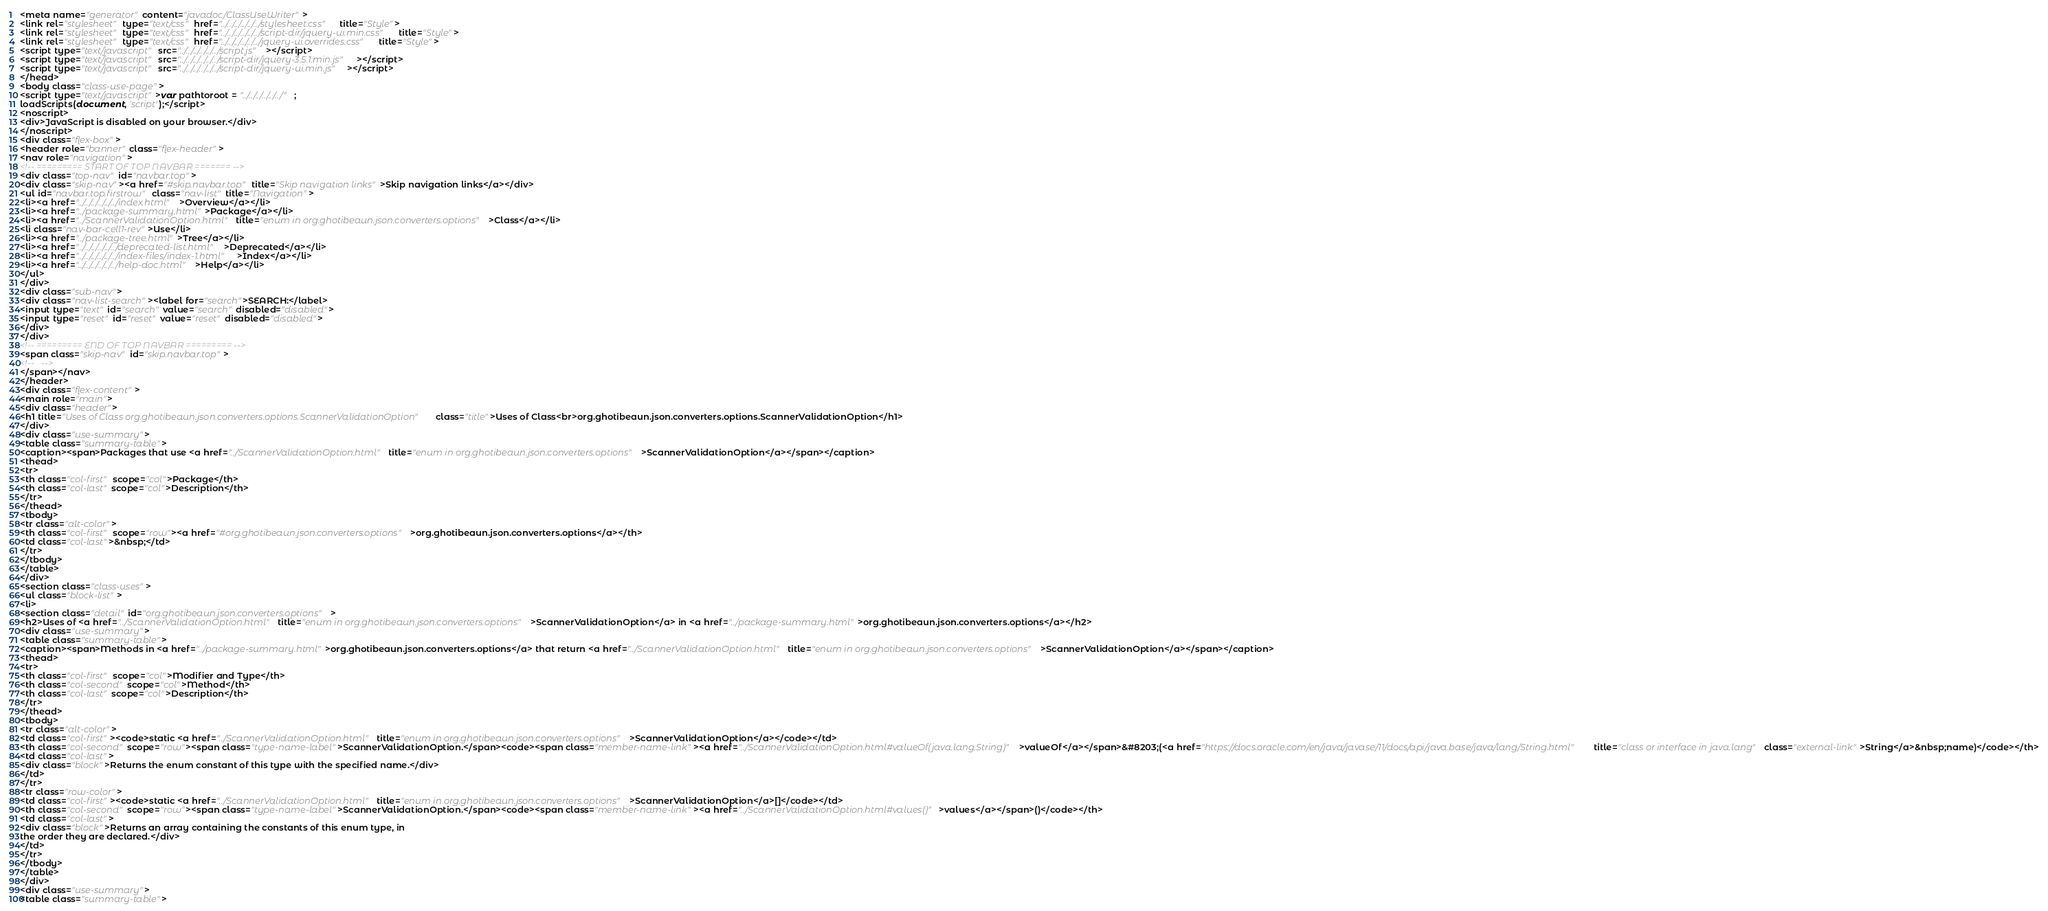Convert code to text. <code><loc_0><loc_0><loc_500><loc_500><_HTML_><meta name="generator" content="javadoc/ClassUseWriter">
<link rel="stylesheet" type="text/css" href="../../../../../../stylesheet.css" title="Style">
<link rel="stylesheet" type="text/css" href="../../../../../../script-dir/jquery-ui.min.css" title="Style">
<link rel="stylesheet" type="text/css" href="../../../../../../jquery-ui.overrides.css" title="Style">
<script type="text/javascript" src="../../../../../../script.js"></script>
<script type="text/javascript" src="../../../../../../script-dir/jquery-3.5.1.min.js"></script>
<script type="text/javascript" src="../../../../../../script-dir/jquery-ui.min.js"></script>
</head>
<body class="class-use-page">
<script type="text/javascript">var pathtoroot = "../../../../../../";
loadScripts(document, 'script');</script>
<noscript>
<div>JavaScript is disabled on your browser.</div>
</noscript>
<div class="flex-box">
<header role="banner" class="flex-header">
<nav role="navigation">
<!-- ========= START OF TOP NAVBAR ======= -->
<div class="top-nav" id="navbar.top">
<div class="skip-nav"><a href="#skip.navbar.top" title="Skip navigation links">Skip navigation links</a></div>
<ul id="navbar.top.firstrow" class="nav-list" title="Navigation">
<li><a href="../../../../../../index.html">Overview</a></li>
<li><a href="../package-summary.html">Package</a></li>
<li><a href="../ScannerValidationOption.html" title="enum in org.ghotibeaun.json.converters.options">Class</a></li>
<li class="nav-bar-cell1-rev">Use</li>
<li><a href="../package-tree.html">Tree</a></li>
<li><a href="../../../../../../deprecated-list.html">Deprecated</a></li>
<li><a href="../../../../../../index-files/index-1.html">Index</a></li>
<li><a href="../../../../../../help-doc.html">Help</a></li>
</ul>
</div>
<div class="sub-nav">
<div class="nav-list-search"><label for="search">SEARCH:</label>
<input type="text" id="search" value="search" disabled="disabled">
<input type="reset" id="reset" value="reset" disabled="disabled">
</div>
</div>
<!-- ========= END OF TOP NAVBAR ========= -->
<span class="skip-nav" id="skip.navbar.top">
<!--   -->
</span></nav>
</header>
<div class="flex-content">
<main role="main">
<div class="header">
<h1 title="Uses of Class org.ghotibeaun.json.converters.options.ScannerValidationOption" class="title">Uses of Class<br>org.ghotibeaun.json.converters.options.ScannerValidationOption</h1>
</div>
<div class="use-summary">
<table class="summary-table">
<caption><span>Packages that use <a href="../ScannerValidationOption.html" title="enum in org.ghotibeaun.json.converters.options">ScannerValidationOption</a></span></caption>
<thead>
<tr>
<th class="col-first" scope="col">Package</th>
<th class="col-last" scope="col">Description</th>
</tr>
</thead>
<tbody>
<tr class="alt-color">
<th class="col-first" scope="row"><a href="#org.ghotibeaun.json.converters.options">org.ghotibeaun.json.converters.options</a></th>
<td class="col-last">&nbsp;</td>
</tr>
</tbody>
</table>
</div>
<section class="class-uses">
<ul class="block-list">
<li>
<section class="detail" id="org.ghotibeaun.json.converters.options">
<h2>Uses of <a href="../ScannerValidationOption.html" title="enum in org.ghotibeaun.json.converters.options">ScannerValidationOption</a> in <a href="../package-summary.html">org.ghotibeaun.json.converters.options</a></h2>
<div class="use-summary">
<table class="summary-table">
<caption><span>Methods in <a href="../package-summary.html">org.ghotibeaun.json.converters.options</a> that return <a href="../ScannerValidationOption.html" title="enum in org.ghotibeaun.json.converters.options">ScannerValidationOption</a></span></caption>
<thead>
<tr>
<th class="col-first" scope="col">Modifier and Type</th>
<th class="col-second" scope="col">Method</th>
<th class="col-last" scope="col">Description</th>
</tr>
</thead>
<tbody>
<tr class="alt-color">
<td class="col-first"><code>static <a href="../ScannerValidationOption.html" title="enum in org.ghotibeaun.json.converters.options">ScannerValidationOption</a></code></td>
<th class="col-second" scope="row"><span class="type-name-label">ScannerValidationOption.</span><code><span class="member-name-link"><a href="../ScannerValidationOption.html#valueOf(java.lang.String)">valueOf</a></span>&#8203;(<a href="https://docs.oracle.com/en/java/javase/11/docs/api/java.base/java/lang/String.html" title="class or interface in java.lang" class="external-link">String</a>&nbsp;name)</code></th>
<td class="col-last">
<div class="block">Returns the enum constant of this type with the specified name.</div>
</td>
</tr>
<tr class="row-color">
<td class="col-first"><code>static <a href="../ScannerValidationOption.html" title="enum in org.ghotibeaun.json.converters.options">ScannerValidationOption</a>[]</code></td>
<th class="col-second" scope="row"><span class="type-name-label">ScannerValidationOption.</span><code><span class="member-name-link"><a href="../ScannerValidationOption.html#values()">values</a></span>()</code></th>
<td class="col-last">
<div class="block">Returns an array containing the constants of this enum type, in
the order they are declared.</div>
</td>
</tr>
</tbody>
</table>
</div>
<div class="use-summary">
<table class="summary-table"></code> 